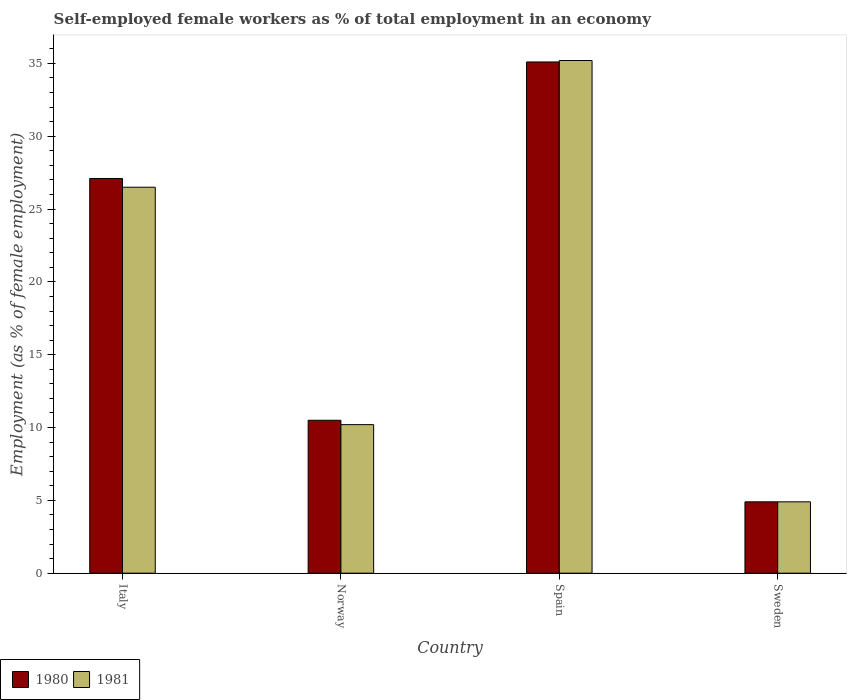How many different coloured bars are there?
Offer a terse response. 2. Are the number of bars on each tick of the X-axis equal?
Give a very brief answer. Yes. In how many cases, is the number of bars for a given country not equal to the number of legend labels?
Make the answer very short. 0. What is the percentage of self-employed female workers in 1980 in Italy?
Give a very brief answer. 27.1. Across all countries, what is the maximum percentage of self-employed female workers in 1981?
Ensure brevity in your answer.  35.2. Across all countries, what is the minimum percentage of self-employed female workers in 1980?
Keep it short and to the point. 4.9. In which country was the percentage of self-employed female workers in 1980 maximum?
Give a very brief answer. Spain. In which country was the percentage of self-employed female workers in 1981 minimum?
Keep it short and to the point. Sweden. What is the total percentage of self-employed female workers in 1980 in the graph?
Offer a terse response. 77.6. What is the difference between the percentage of self-employed female workers in 1981 in Italy and that in Norway?
Ensure brevity in your answer.  16.3. What is the difference between the percentage of self-employed female workers in 1980 in Sweden and the percentage of self-employed female workers in 1981 in Norway?
Keep it short and to the point. -5.3. What is the average percentage of self-employed female workers in 1980 per country?
Ensure brevity in your answer.  19.4. What is the difference between the percentage of self-employed female workers of/in 1981 and percentage of self-employed female workers of/in 1980 in Italy?
Your answer should be very brief. -0.6. In how many countries, is the percentage of self-employed female workers in 1980 greater than 18 %?
Provide a succinct answer. 2. What is the ratio of the percentage of self-employed female workers in 1980 in Norway to that in Spain?
Provide a short and direct response. 0.3. Is the difference between the percentage of self-employed female workers in 1981 in Italy and Norway greater than the difference between the percentage of self-employed female workers in 1980 in Italy and Norway?
Your answer should be very brief. No. What is the difference between the highest and the second highest percentage of self-employed female workers in 1981?
Provide a succinct answer. -8.7. What is the difference between the highest and the lowest percentage of self-employed female workers in 1981?
Make the answer very short. 30.3. Is the sum of the percentage of self-employed female workers in 1981 in Norway and Spain greater than the maximum percentage of self-employed female workers in 1980 across all countries?
Your answer should be very brief. Yes. What does the 2nd bar from the left in Norway represents?
Offer a terse response. 1981. What does the 2nd bar from the right in Italy represents?
Give a very brief answer. 1980. How many bars are there?
Offer a very short reply. 8. How many countries are there in the graph?
Your answer should be very brief. 4. What is the difference between two consecutive major ticks on the Y-axis?
Offer a very short reply. 5. Are the values on the major ticks of Y-axis written in scientific E-notation?
Your answer should be very brief. No. Where does the legend appear in the graph?
Your answer should be very brief. Bottom left. How many legend labels are there?
Give a very brief answer. 2. What is the title of the graph?
Keep it short and to the point. Self-employed female workers as % of total employment in an economy. What is the label or title of the Y-axis?
Ensure brevity in your answer.  Employment (as % of female employment). What is the Employment (as % of female employment) in 1980 in Italy?
Provide a short and direct response. 27.1. What is the Employment (as % of female employment) of 1981 in Italy?
Your answer should be very brief. 26.5. What is the Employment (as % of female employment) of 1981 in Norway?
Provide a short and direct response. 10.2. What is the Employment (as % of female employment) of 1980 in Spain?
Give a very brief answer. 35.1. What is the Employment (as % of female employment) in 1981 in Spain?
Offer a terse response. 35.2. What is the Employment (as % of female employment) in 1980 in Sweden?
Give a very brief answer. 4.9. What is the Employment (as % of female employment) of 1981 in Sweden?
Your answer should be very brief. 4.9. Across all countries, what is the maximum Employment (as % of female employment) in 1980?
Offer a very short reply. 35.1. Across all countries, what is the maximum Employment (as % of female employment) of 1981?
Keep it short and to the point. 35.2. Across all countries, what is the minimum Employment (as % of female employment) of 1980?
Your answer should be very brief. 4.9. Across all countries, what is the minimum Employment (as % of female employment) of 1981?
Give a very brief answer. 4.9. What is the total Employment (as % of female employment) in 1980 in the graph?
Provide a short and direct response. 77.6. What is the total Employment (as % of female employment) of 1981 in the graph?
Your answer should be compact. 76.8. What is the difference between the Employment (as % of female employment) in 1980 in Italy and that in Norway?
Your response must be concise. 16.6. What is the difference between the Employment (as % of female employment) of 1981 in Italy and that in Norway?
Your answer should be compact. 16.3. What is the difference between the Employment (as % of female employment) of 1980 in Italy and that in Spain?
Your answer should be compact. -8. What is the difference between the Employment (as % of female employment) of 1980 in Italy and that in Sweden?
Provide a succinct answer. 22.2. What is the difference between the Employment (as % of female employment) of 1981 in Italy and that in Sweden?
Make the answer very short. 21.6. What is the difference between the Employment (as % of female employment) in 1980 in Norway and that in Spain?
Your answer should be compact. -24.6. What is the difference between the Employment (as % of female employment) in 1981 in Norway and that in Spain?
Your answer should be compact. -25. What is the difference between the Employment (as % of female employment) of 1980 in Norway and that in Sweden?
Make the answer very short. 5.6. What is the difference between the Employment (as % of female employment) of 1980 in Spain and that in Sweden?
Provide a short and direct response. 30.2. What is the difference between the Employment (as % of female employment) in 1981 in Spain and that in Sweden?
Your response must be concise. 30.3. What is the difference between the Employment (as % of female employment) in 1980 in Italy and the Employment (as % of female employment) in 1981 in Sweden?
Provide a short and direct response. 22.2. What is the difference between the Employment (as % of female employment) in 1980 in Norway and the Employment (as % of female employment) in 1981 in Spain?
Make the answer very short. -24.7. What is the difference between the Employment (as % of female employment) in 1980 in Norway and the Employment (as % of female employment) in 1981 in Sweden?
Provide a short and direct response. 5.6. What is the difference between the Employment (as % of female employment) of 1980 in Spain and the Employment (as % of female employment) of 1981 in Sweden?
Ensure brevity in your answer.  30.2. What is the average Employment (as % of female employment) of 1981 per country?
Keep it short and to the point. 19.2. What is the difference between the Employment (as % of female employment) of 1980 and Employment (as % of female employment) of 1981 in Norway?
Offer a terse response. 0.3. What is the difference between the Employment (as % of female employment) of 1980 and Employment (as % of female employment) of 1981 in Sweden?
Provide a short and direct response. 0. What is the ratio of the Employment (as % of female employment) in 1980 in Italy to that in Norway?
Your answer should be very brief. 2.58. What is the ratio of the Employment (as % of female employment) in 1981 in Italy to that in Norway?
Provide a succinct answer. 2.6. What is the ratio of the Employment (as % of female employment) in 1980 in Italy to that in Spain?
Make the answer very short. 0.77. What is the ratio of the Employment (as % of female employment) in 1981 in Italy to that in Spain?
Give a very brief answer. 0.75. What is the ratio of the Employment (as % of female employment) in 1980 in Italy to that in Sweden?
Keep it short and to the point. 5.53. What is the ratio of the Employment (as % of female employment) of 1981 in Italy to that in Sweden?
Ensure brevity in your answer.  5.41. What is the ratio of the Employment (as % of female employment) in 1980 in Norway to that in Spain?
Offer a terse response. 0.3. What is the ratio of the Employment (as % of female employment) of 1981 in Norway to that in Spain?
Offer a terse response. 0.29. What is the ratio of the Employment (as % of female employment) in 1980 in Norway to that in Sweden?
Ensure brevity in your answer.  2.14. What is the ratio of the Employment (as % of female employment) in 1981 in Norway to that in Sweden?
Your response must be concise. 2.08. What is the ratio of the Employment (as % of female employment) of 1980 in Spain to that in Sweden?
Your response must be concise. 7.16. What is the ratio of the Employment (as % of female employment) of 1981 in Spain to that in Sweden?
Your answer should be very brief. 7.18. What is the difference between the highest and the second highest Employment (as % of female employment) in 1980?
Your answer should be very brief. 8. What is the difference between the highest and the lowest Employment (as % of female employment) in 1980?
Ensure brevity in your answer.  30.2. What is the difference between the highest and the lowest Employment (as % of female employment) of 1981?
Ensure brevity in your answer.  30.3. 